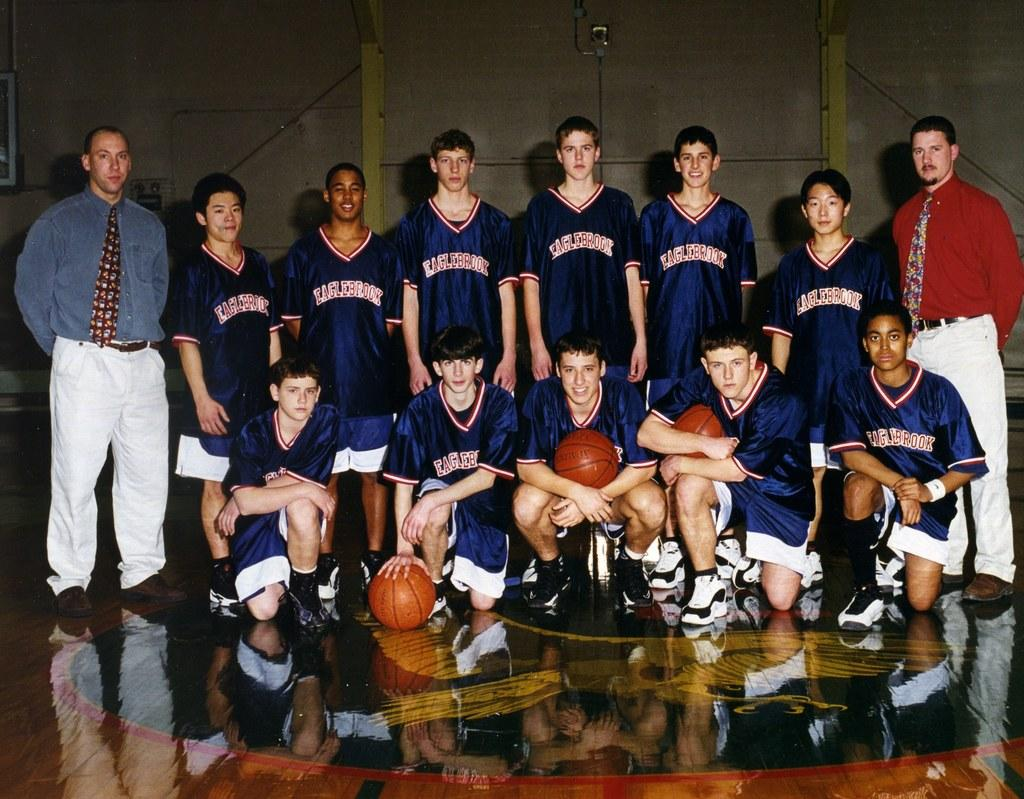<image>
Render a clear and concise summary of the photo. a few people posing with the name Eaglebrook on the jerseys 